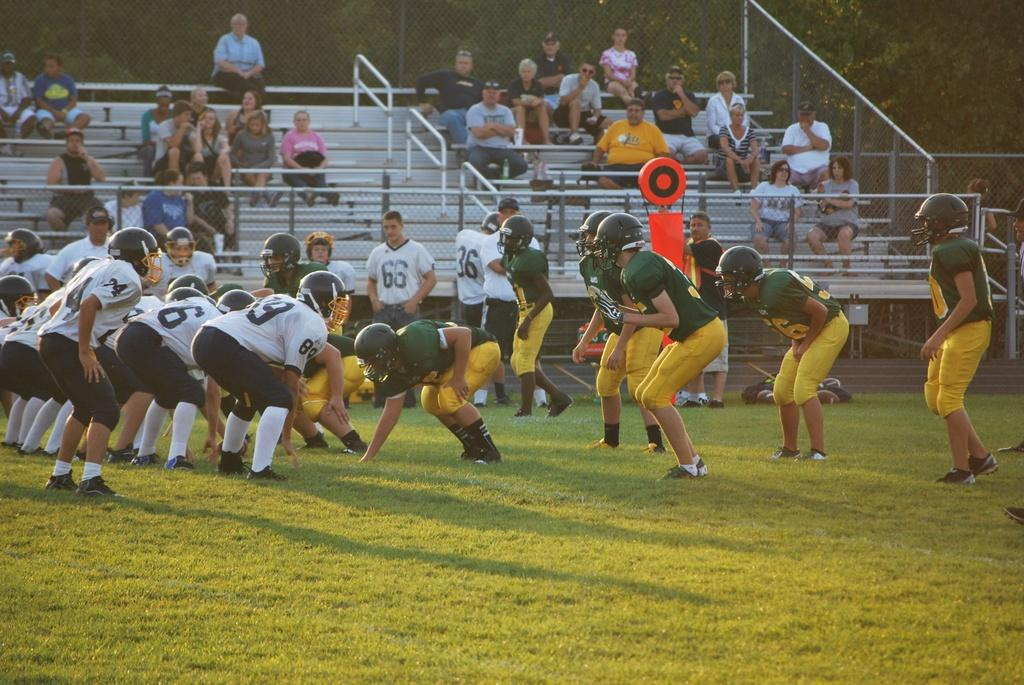What sport are the players in the image participating in? The rugby players in the image are participating in a game of rugby. What can be seen in the background of the image? There are people sitting in the backdrop of the image. What type of natural environment is visible in the image? There are trees visible in the image. What type of root is being used by the rugby players in the image? There is no root present in the image; it features rugby players playing a game. What kind of experience can be gained from watching the rugby players in the image? The image does not convey any specific experience, as it only shows rugby players playing a game. 